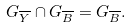Convert formula to latex. <formula><loc_0><loc_0><loc_500><loc_500>G _ { \overline { Y } } \cap G _ { \overline { B } } = G _ { \overline { B } } .</formula> 